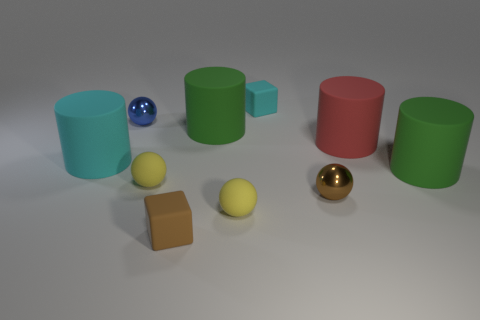There is a large cyan rubber thing; is its shape the same as the green rubber thing that is left of the red matte object?
Your answer should be very brief. Yes. Are there fewer big cyan rubber cylinders in front of the brown block than brown shiny balls behind the large cyan thing?
Offer a terse response. No. What is the material of the red thing that is the same shape as the big cyan rubber object?
Provide a short and direct response. Rubber. What is the shape of the big red thing that is made of the same material as the large cyan thing?
Make the answer very short. Cylinder. How many brown rubber objects are the same shape as the small cyan rubber thing?
Ensure brevity in your answer.  1. There is a tiny brown thing that is behind the brown matte thing to the left of the big red matte cylinder; what shape is it?
Your response must be concise. Sphere. There is a green matte cylinder that is left of the brown sphere; is it the same size as the small blue object?
Give a very brief answer. No. There is a matte cylinder that is both left of the red thing and in front of the big red matte thing; what size is it?
Offer a very short reply. Large. How many brown spheres are the same size as the blue ball?
Provide a short and direct response. 1. How many tiny cyan objects are to the right of the green rubber thing that is behind the cyan cylinder?
Offer a very short reply. 1. 